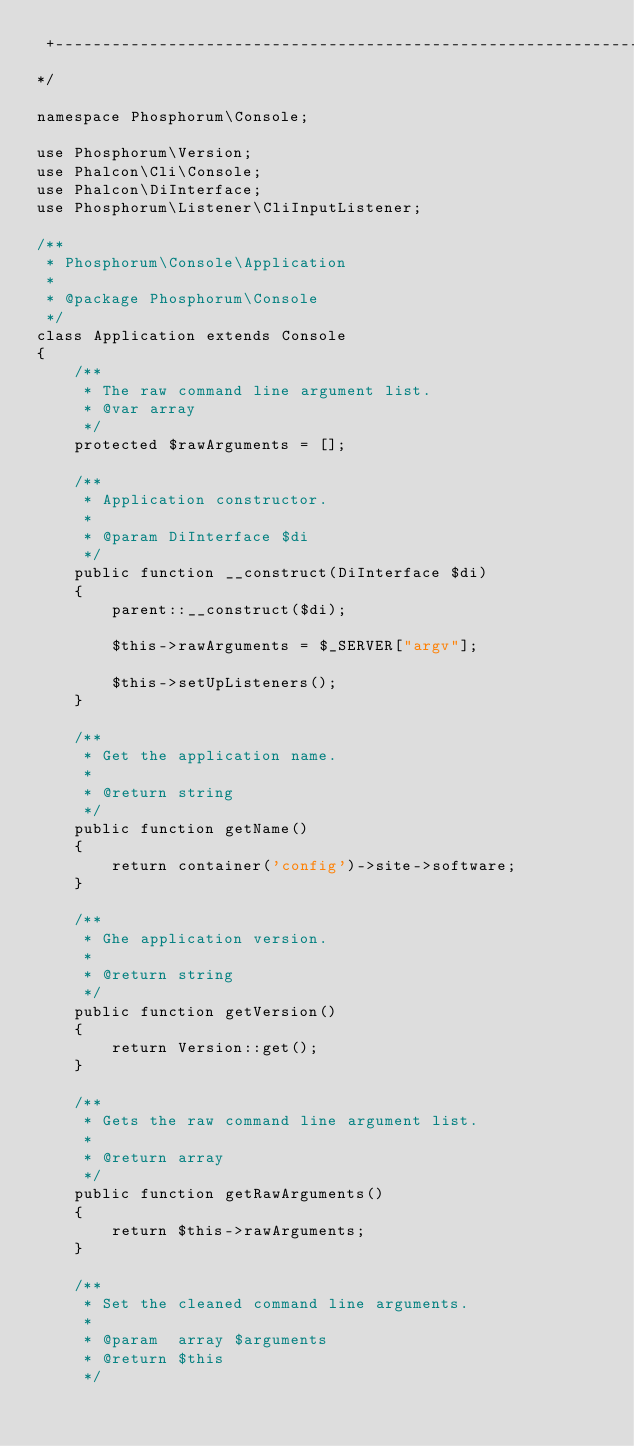<code> <loc_0><loc_0><loc_500><loc_500><_PHP_> +------------------------------------------------------------------------+
*/

namespace Phosphorum\Console;

use Phosphorum\Version;
use Phalcon\Cli\Console;
use Phalcon\DiInterface;
use Phosphorum\Listener\CliInputListener;

/**
 * Phosphorum\Console\Application
 *
 * @package Phosphorum\Console
 */
class Application extends Console
{
    /**
     * The raw command line argument list.
     * @var array
     */
    protected $rawArguments = [];

    /**
     * Application constructor.
     *
     * @param DiInterface $di
     */
    public function __construct(DiInterface $di)
    {
        parent::__construct($di);

        $this->rawArguments = $_SERVER["argv"];

        $this->setUpListeners();
    }

    /**
     * Get the application name.
     *
     * @return string
     */
    public function getName()
    {
        return container('config')->site->software;
    }

    /**
     * Ghe application version.
     *
     * @return string
     */
    public function getVersion()
    {
        return Version::get();
    }

    /**
     * Gets the raw command line argument list.
     *
     * @return array
     */
    public function getRawArguments()
    {
        return $this->rawArguments;
    }

    /**
     * Set the cleaned command line arguments.
     *
     * @param  array $arguments
     * @return $this
     */</code> 